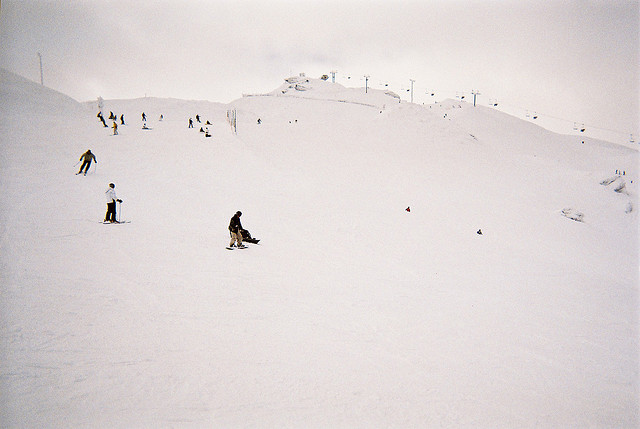<image>What animal is in the picture? I don't know what animal is in the picture. It could be humans, dogs, or birds. What animal is in the picture? There is no animal in the picture. However, there are people in the picture. 